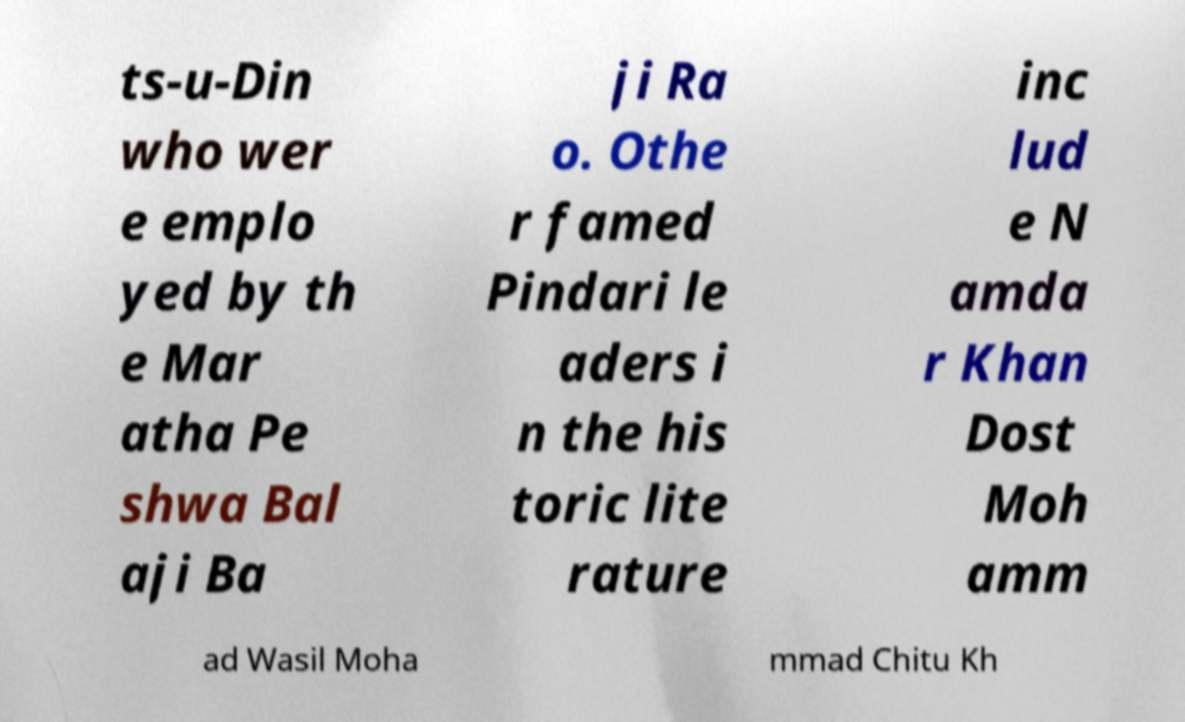Please identify and transcribe the text found in this image. ts-u-Din who wer e emplo yed by th e Mar atha Pe shwa Bal aji Ba ji Ra o. Othe r famed Pindari le aders i n the his toric lite rature inc lud e N amda r Khan Dost Moh amm ad Wasil Moha mmad Chitu Kh 